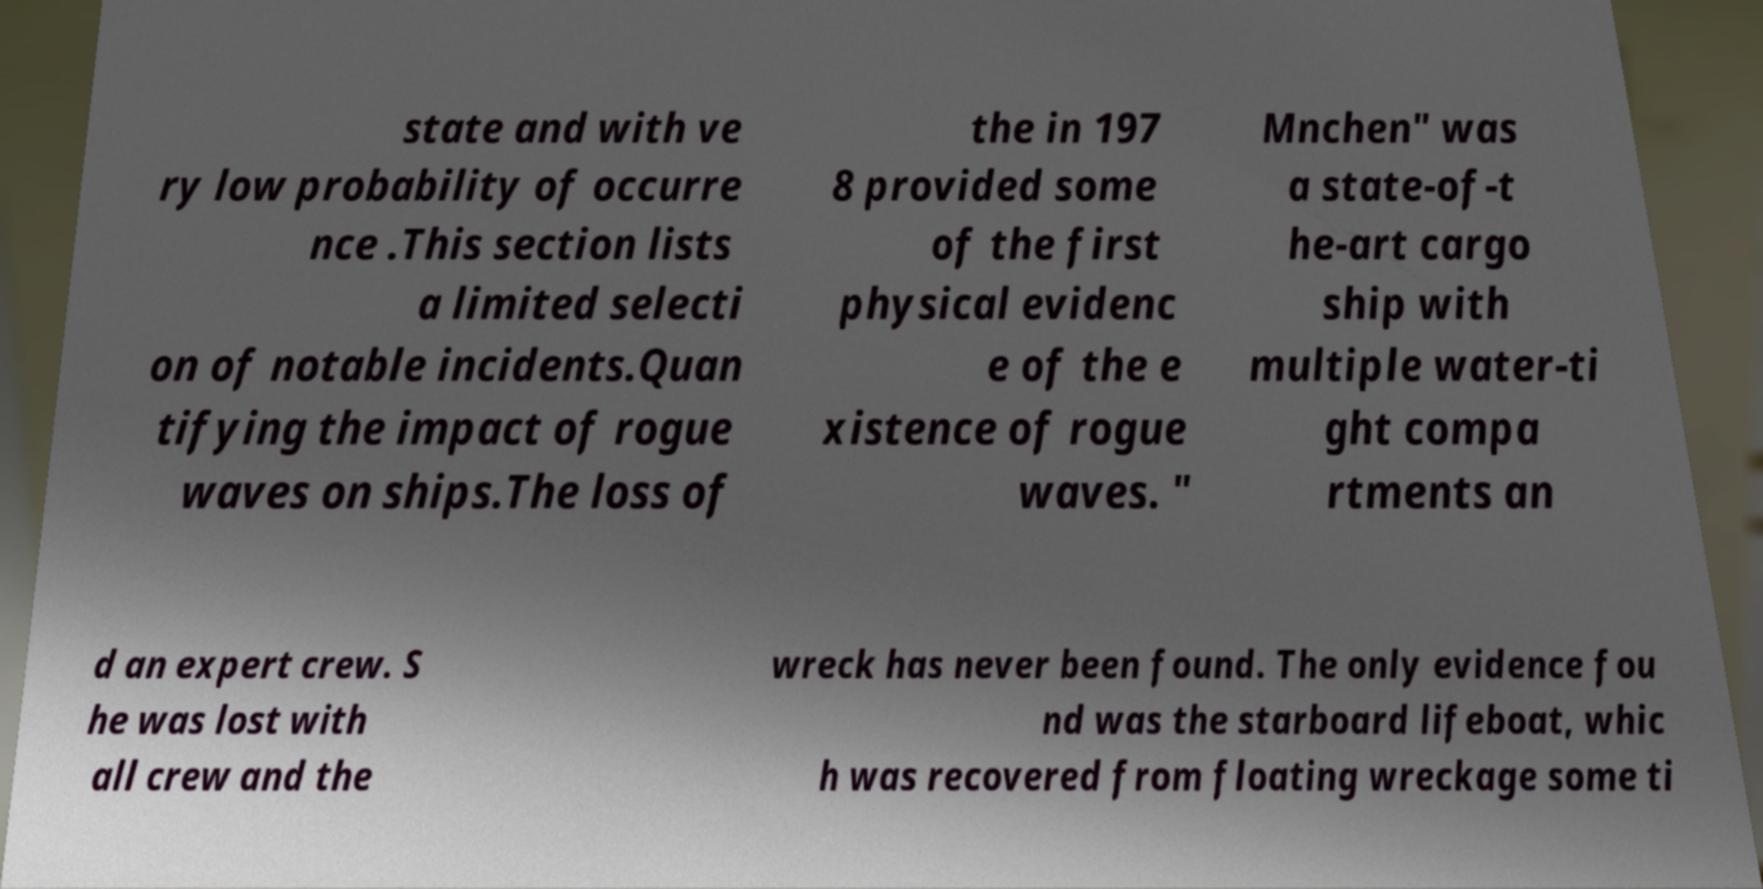Please identify and transcribe the text found in this image. state and with ve ry low probability of occurre nce .This section lists a limited selecti on of notable incidents.Quan tifying the impact of rogue waves on ships.The loss of the in 197 8 provided some of the first physical evidenc e of the e xistence of rogue waves. " Mnchen" was a state-of-t he-art cargo ship with multiple water-ti ght compa rtments an d an expert crew. S he was lost with all crew and the wreck has never been found. The only evidence fou nd was the starboard lifeboat, whic h was recovered from floating wreckage some ti 